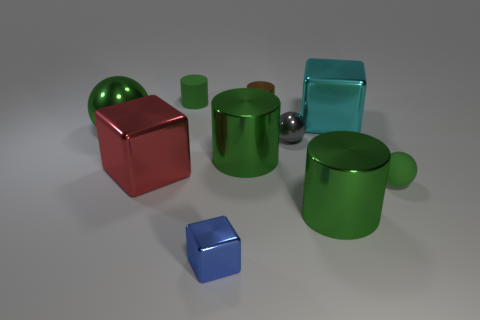What is the shape of the small metallic thing that is behind the gray thing that is in front of the tiny cylinder on the left side of the tiny blue block?
Offer a terse response. Cylinder. What is the material of the blue cube?
Offer a very short reply. Metal. What color is the small cylinder that is made of the same material as the small blue cube?
Provide a short and direct response. Brown. There is a green object that is behind the cyan thing; is there a red metal cube that is behind it?
Offer a very short reply. No. What number of other things are there of the same shape as the small gray object?
Keep it short and to the point. 2. There is a tiny rubber thing that is on the right side of the brown cylinder; does it have the same shape as the blue thing in front of the big green ball?
Provide a short and direct response. No. What number of tiny rubber cylinders are on the left side of the large cylinder right of the metal sphere that is on the right side of the large green sphere?
Provide a succinct answer. 1. The tiny rubber cylinder is what color?
Your response must be concise. Green. What number of other objects are the same size as the cyan metallic cube?
Make the answer very short. 4. There is a blue object that is the same shape as the big cyan thing; what is it made of?
Offer a terse response. Metal. 